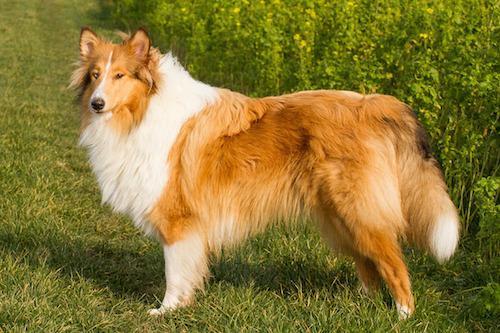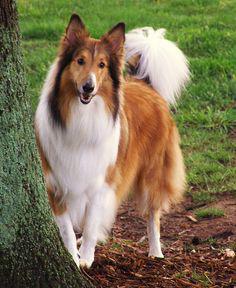The first image is the image on the left, the second image is the image on the right. Given the left and right images, does the statement "The dog in one of the images is sitting and looking toward the camera." hold true? Answer yes or no. No. 